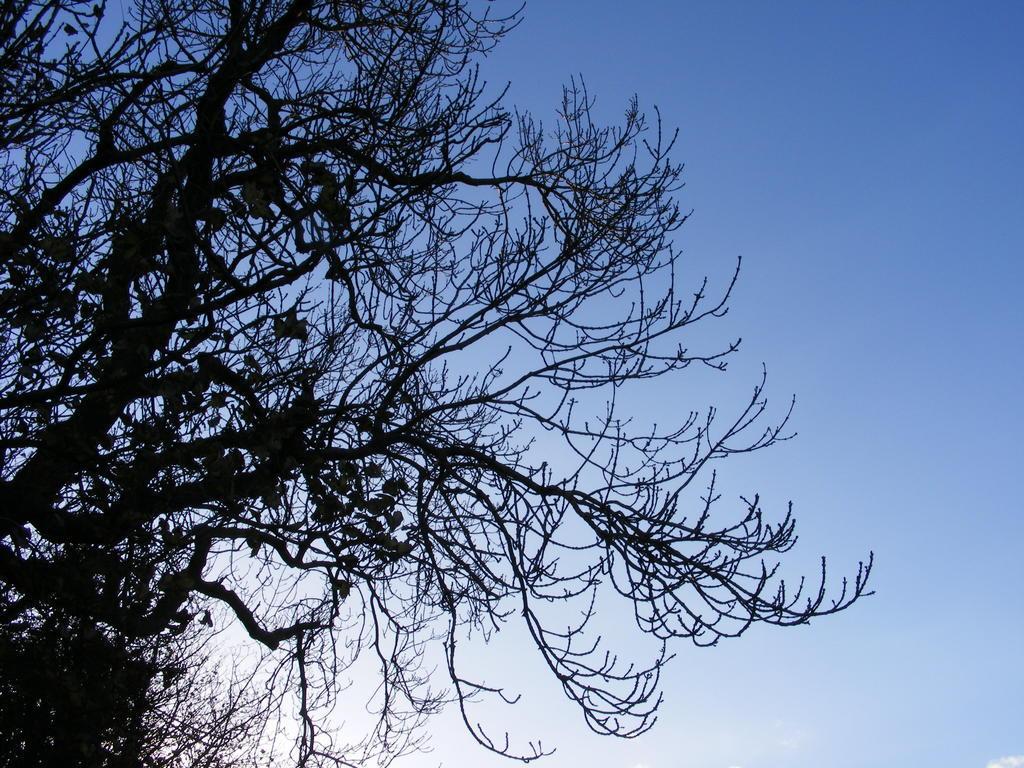Please provide a concise description of this image. On the left side of the image, we can see trees. Background we can see the sky. 